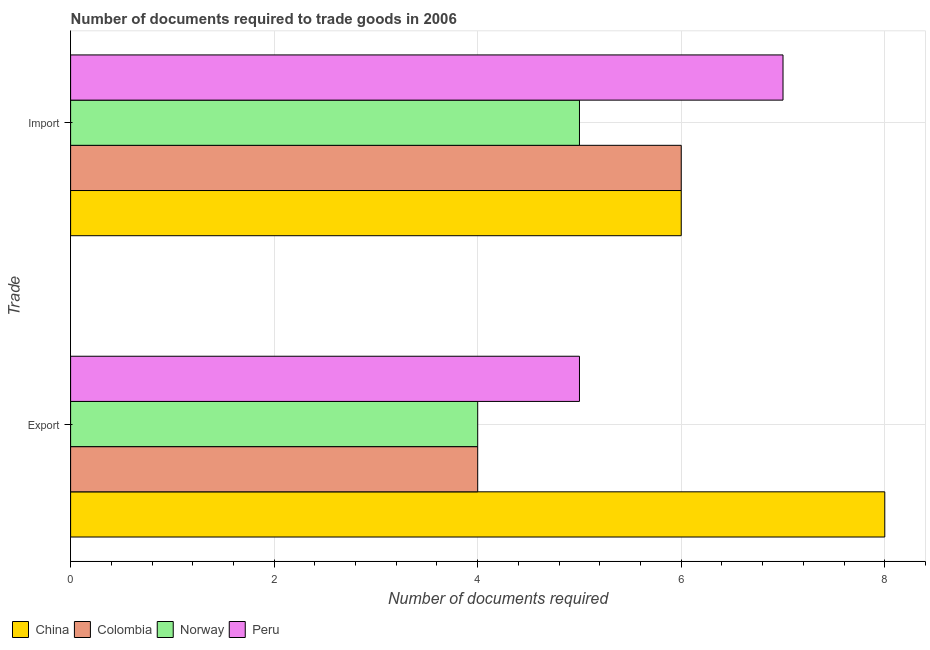Are the number of bars on each tick of the Y-axis equal?
Your answer should be very brief. Yes. How many bars are there on the 1st tick from the bottom?
Ensure brevity in your answer.  4. What is the label of the 1st group of bars from the top?
Provide a succinct answer. Import. What is the number of documents required to import goods in Norway?
Make the answer very short. 5. Across all countries, what is the maximum number of documents required to export goods?
Your answer should be compact. 8. Across all countries, what is the minimum number of documents required to export goods?
Provide a short and direct response. 4. In which country was the number of documents required to import goods maximum?
Provide a short and direct response. Peru. What is the total number of documents required to export goods in the graph?
Provide a succinct answer. 21. What is the difference between the number of documents required to import goods in Colombia and that in Peru?
Your answer should be very brief. -1. What is the difference between the number of documents required to import goods in China and the number of documents required to export goods in Colombia?
Give a very brief answer. 2. What is the average number of documents required to export goods per country?
Your answer should be compact. 5.25. What is the difference between the number of documents required to export goods and number of documents required to import goods in Peru?
Your answer should be very brief. -2. What does the 3rd bar from the top in Import represents?
Offer a very short reply. Colombia. How many bars are there?
Your response must be concise. 8. What is the difference between two consecutive major ticks on the X-axis?
Your response must be concise. 2. Does the graph contain grids?
Your answer should be compact. Yes. Where does the legend appear in the graph?
Keep it short and to the point. Bottom left. How many legend labels are there?
Give a very brief answer. 4. How are the legend labels stacked?
Offer a terse response. Horizontal. What is the title of the graph?
Make the answer very short. Number of documents required to trade goods in 2006. What is the label or title of the X-axis?
Give a very brief answer. Number of documents required. What is the label or title of the Y-axis?
Make the answer very short. Trade. What is the Number of documents required of China in Export?
Offer a very short reply. 8. What is the Number of documents required of Norway in Export?
Provide a succinct answer. 4. What is the Number of documents required in Peru in Export?
Your response must be concise. 5. What is the Number of documents required in Colombia in Import?
Your answer should be compact. 6. What is the Number of documents required of Norway in Import?
Ensure brevity in your answer.  5. Across all Trade, what is the maximum Number of documents required of Norway?
Provide a succinct answer. 5. Across all Trade, what is the maximum Number of documents required in Peru?
Your response must be concise. 7. Across all Trade, what is the minimum Number of documents required of Peru?
Provide a short and direct response. 5. What is the total Number of documents required of China in the graph?
Your response must be concise. 14. What is the total Number of documents required of Colombia in the graph?
Your answer should be very brief. 10. What is the total Number of documents required in Norway in the graph?
Ensure brevity in your answer.  9. What is the total Number of documents required of Peru in the graph?
Provide a short and direct response. 12. What is the difference between the Number of documents required of Norway in Export and that in Import?
Your answer should be compact. -1. What is the difference between the Number of documents required in Peru in Export and that in Import?
Offer a terse response. -2. What is the difference between the Number of documents required of China in Export and the Number of documents required of Colombia in Import?
Keep it short and to the point. 2. What is the difference between the Number of documents required of China in Export and the Number of documents required of Peru in Import?
Give a very brief answer. 1. What is the difference between the Number of documents required of Colombia in Export and the Number of documents required of Norway in Import?
Keep it short and to the point. -1. What is the difference between the Number of documents required of Norway in Export and the Number of documents required of Peru in Import?
Your response must be concise. -3. What is the average Number of documents required of Colombia per Trade?
Offer a terse response. 5. What is the average Number of documents required in Peru per Trade?
Keep it short and to the point. 6. What is the difference between the Number of documents required of China and Number of documents required of Norway in Export?
Provide a succinct answer. 4. What is the difference between the Number of documents required in Colombia and Number of documents required in Norway in Export?
Ensure brevity in your answer.  0. What is the difference between the Number of documents required of Colombia and Number of documents required of Peru in Export?
Your answer should be very brief. -1. What is the difference between the Number of documents required in China and Number of documents required in Norway in Import?
Your answer should be compact. 1. What is the difference between the Number of documents required of China and Number of documents required of Peru in Import?
Your response must be concise. -1. What is the difference between the Number of documents required in Colombia and Number of documents required in Norway in Import?
Your answer should be very brief. 1. What is the ratio of the Number of documents required in China in Export to that in Import?
Your answer should be very brief. 1.33. What is the ratio of the Number of documents required of Colombia in Export to that in Import?
Offer a terse response. 0.67. What is the ratio of the Number of documents required in Norway in Export to that in Import?
Ensure brevity in your answer.  0.8. What is the ratio of the Number of documents required of Peru in Export to that in Import?
Keep it short and to the point. 0.71. What is the difference between the highest and the second highest Number of documents required in China?
Make the answer very short. 2. What is the difference between the highest and the second highest Number of documents required of Norway?
Provide a succinct answer. 1. What is the difference between the highest and the lowest Number of documents required in China?
Provide a short and direct response. 2. 